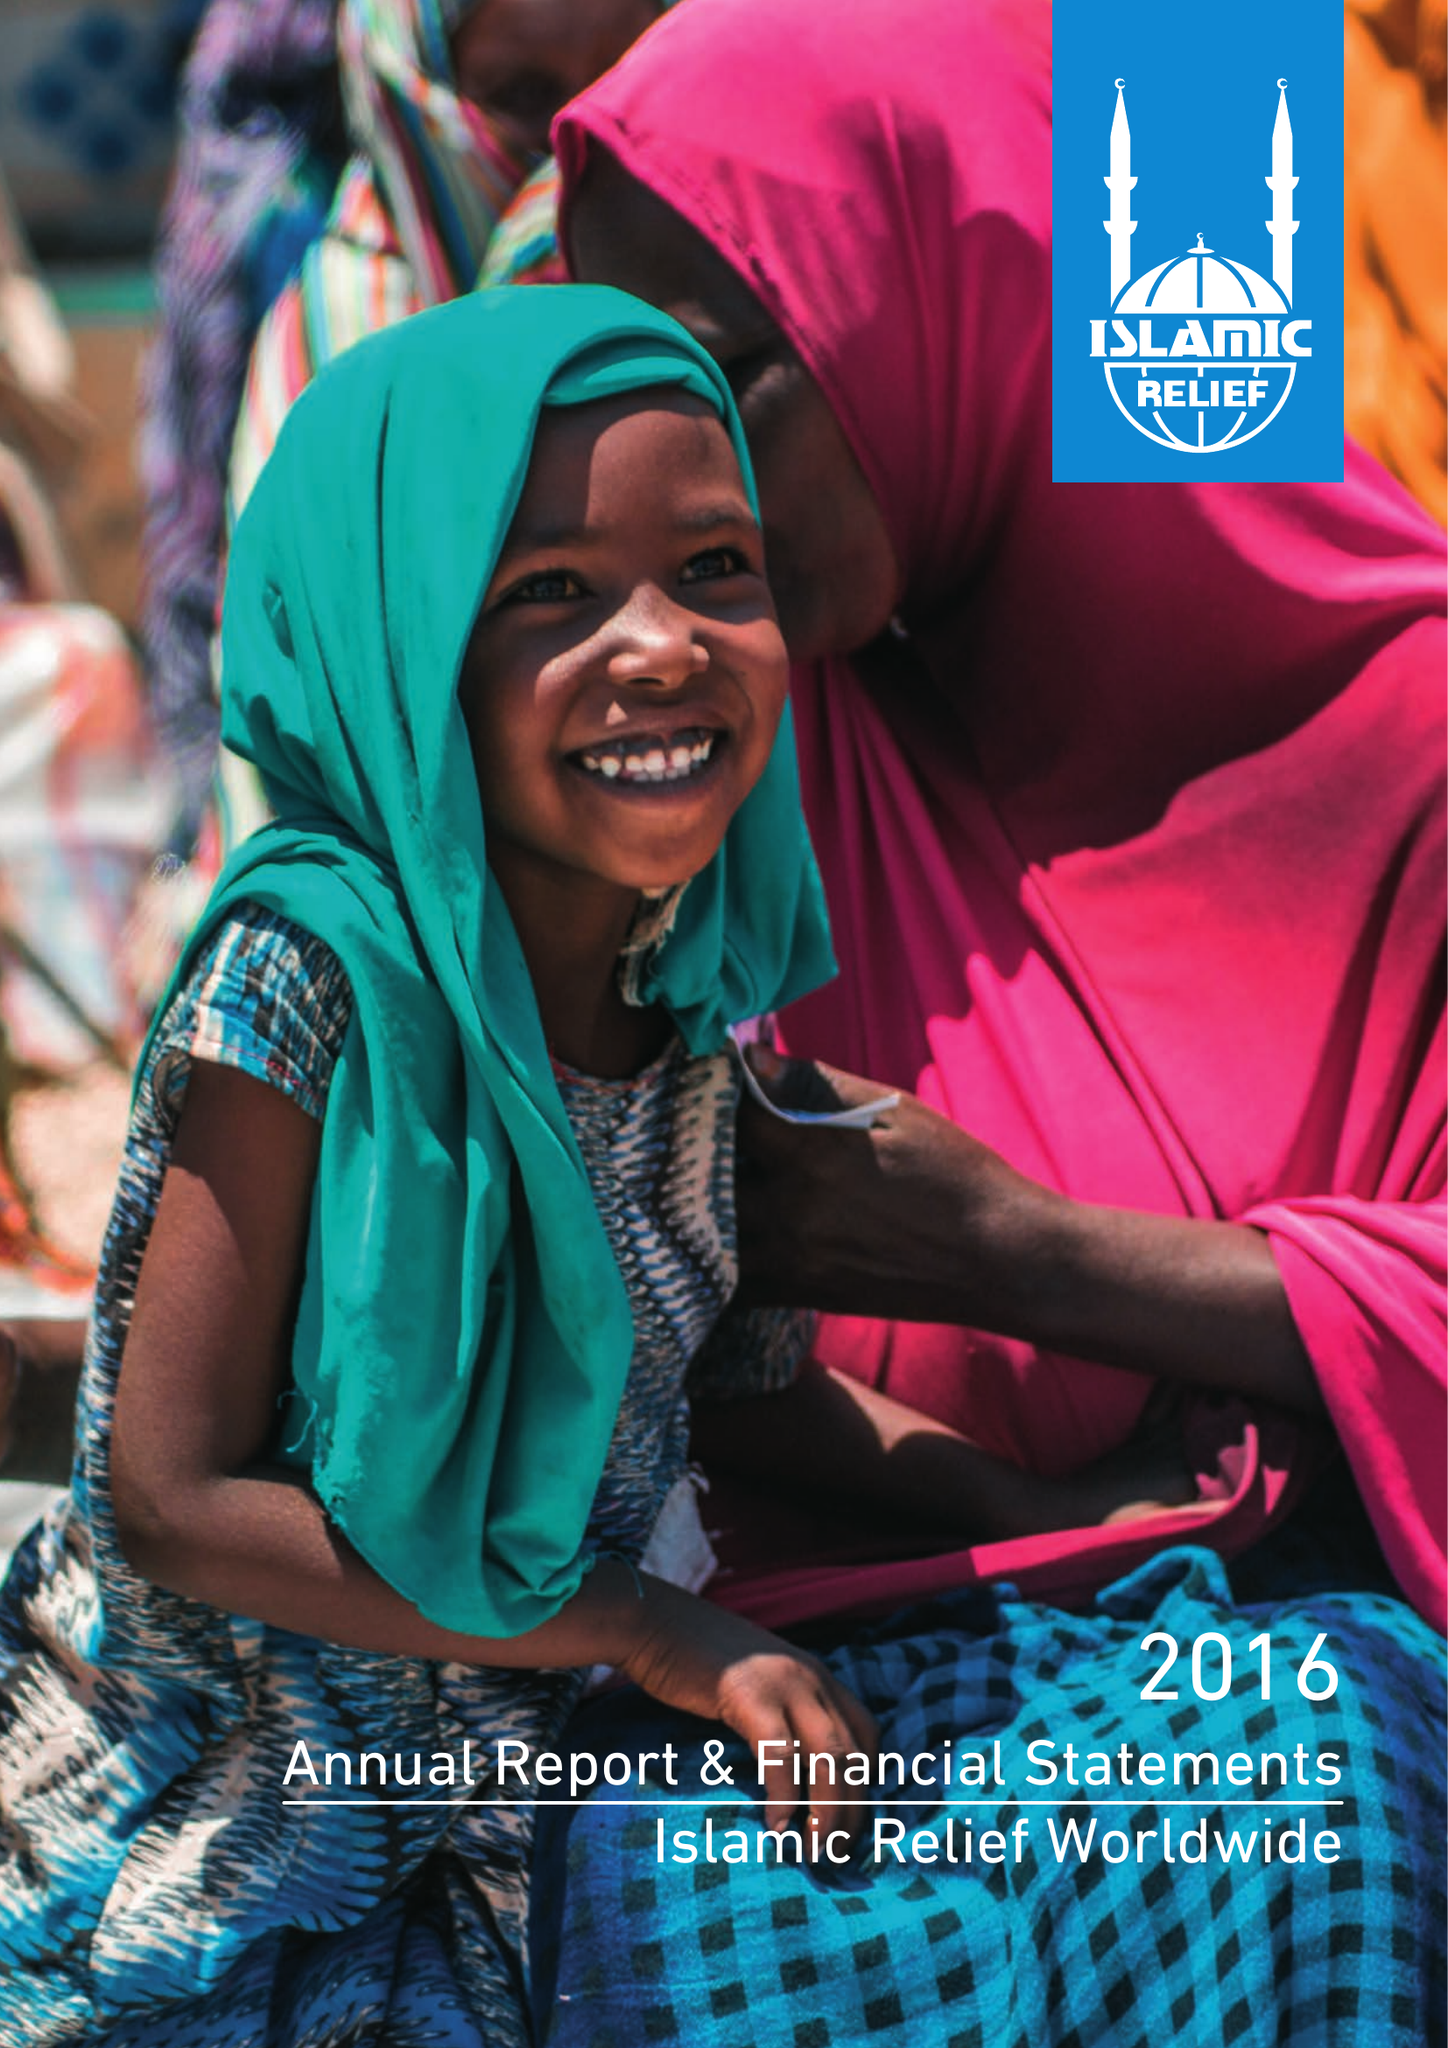What is the value for the address__street_line?
Answer the question using a single word or phrase. 19 REA STREET SOUTH 